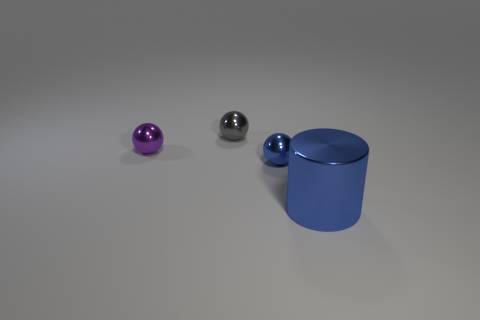Subtract all cylinders. How many objects are left? 3 Add 4 small purple things. How many objects exist? 8 Add 1 small purple metallic spheres. How many small purple metallic spheres are left? 2 Add 4 purple shiny things. How many purple shiny things exist? 5 Subtract 0 cyan blocks. How many objects are left? 4 Subtract all cylinders. Subtract all metallic balls. How many objects are left? 0 